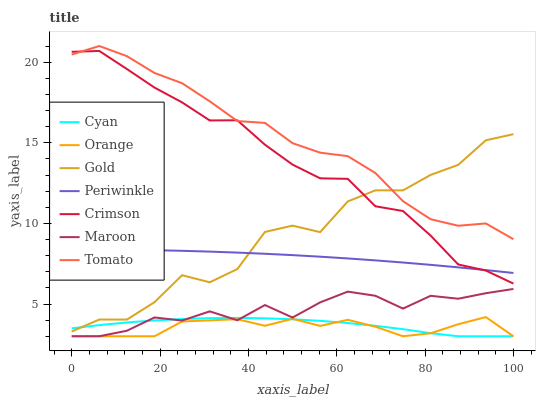Does Orange have the minimum area under the curve?
Answer yes or no. Yes. Does Tomato have the maximum area under the curve?
Answer yes or no. Yes. Does Gold have the minimum area under the curve?
Answer yes or no. No. Does Gold have the maximum area under the curve?
Answer yes or no. No. Is Periwinkle the smoothest?
Answer yes or no. Yes. Is Gold the roughest?
Answer yes or no. Yes. Is Maroon the smoothest?
Answer yes or no. No. Is Maroon the roughest?
Answer yes or no. No. Does Maroon have the lowest value?
Answer yes or no. Yes. Does Gold have the lowest value?
Answer yes or no. No. Does Tomato have the highest value?
Answer yes or no. Yes. Does Gold have the highest value?
Answer yes or no. No. Is Periwinkle less than Tomato?
Answer yes or no. Yes. Is Gold greater than Maroon?
Answer yes or no. Yes. Does Gold intersect Cyan?
Answer yes or no. Yes. Is Gold less than Cyan?
Answer yes or no. No. Is Gold greater than Cyan?
Answer yes or no. No. Does Periwinkle intersect Tomato?
Answer yes or no. No. 